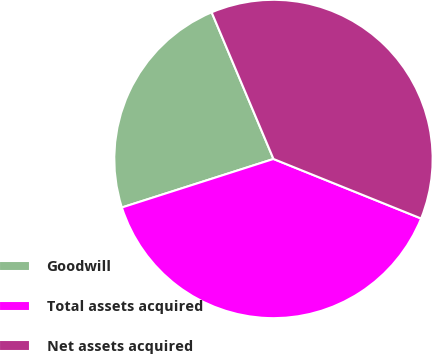<chart> <loc_0><loc_0><loc_500><loc_500><pie_chart><fcel>Goodwill<fcel>Total assets acquired<fcel>Net assets acquired<nl><fcel>23.58%<fcel>38.97%<fcel>37.45%<nl></chart> 